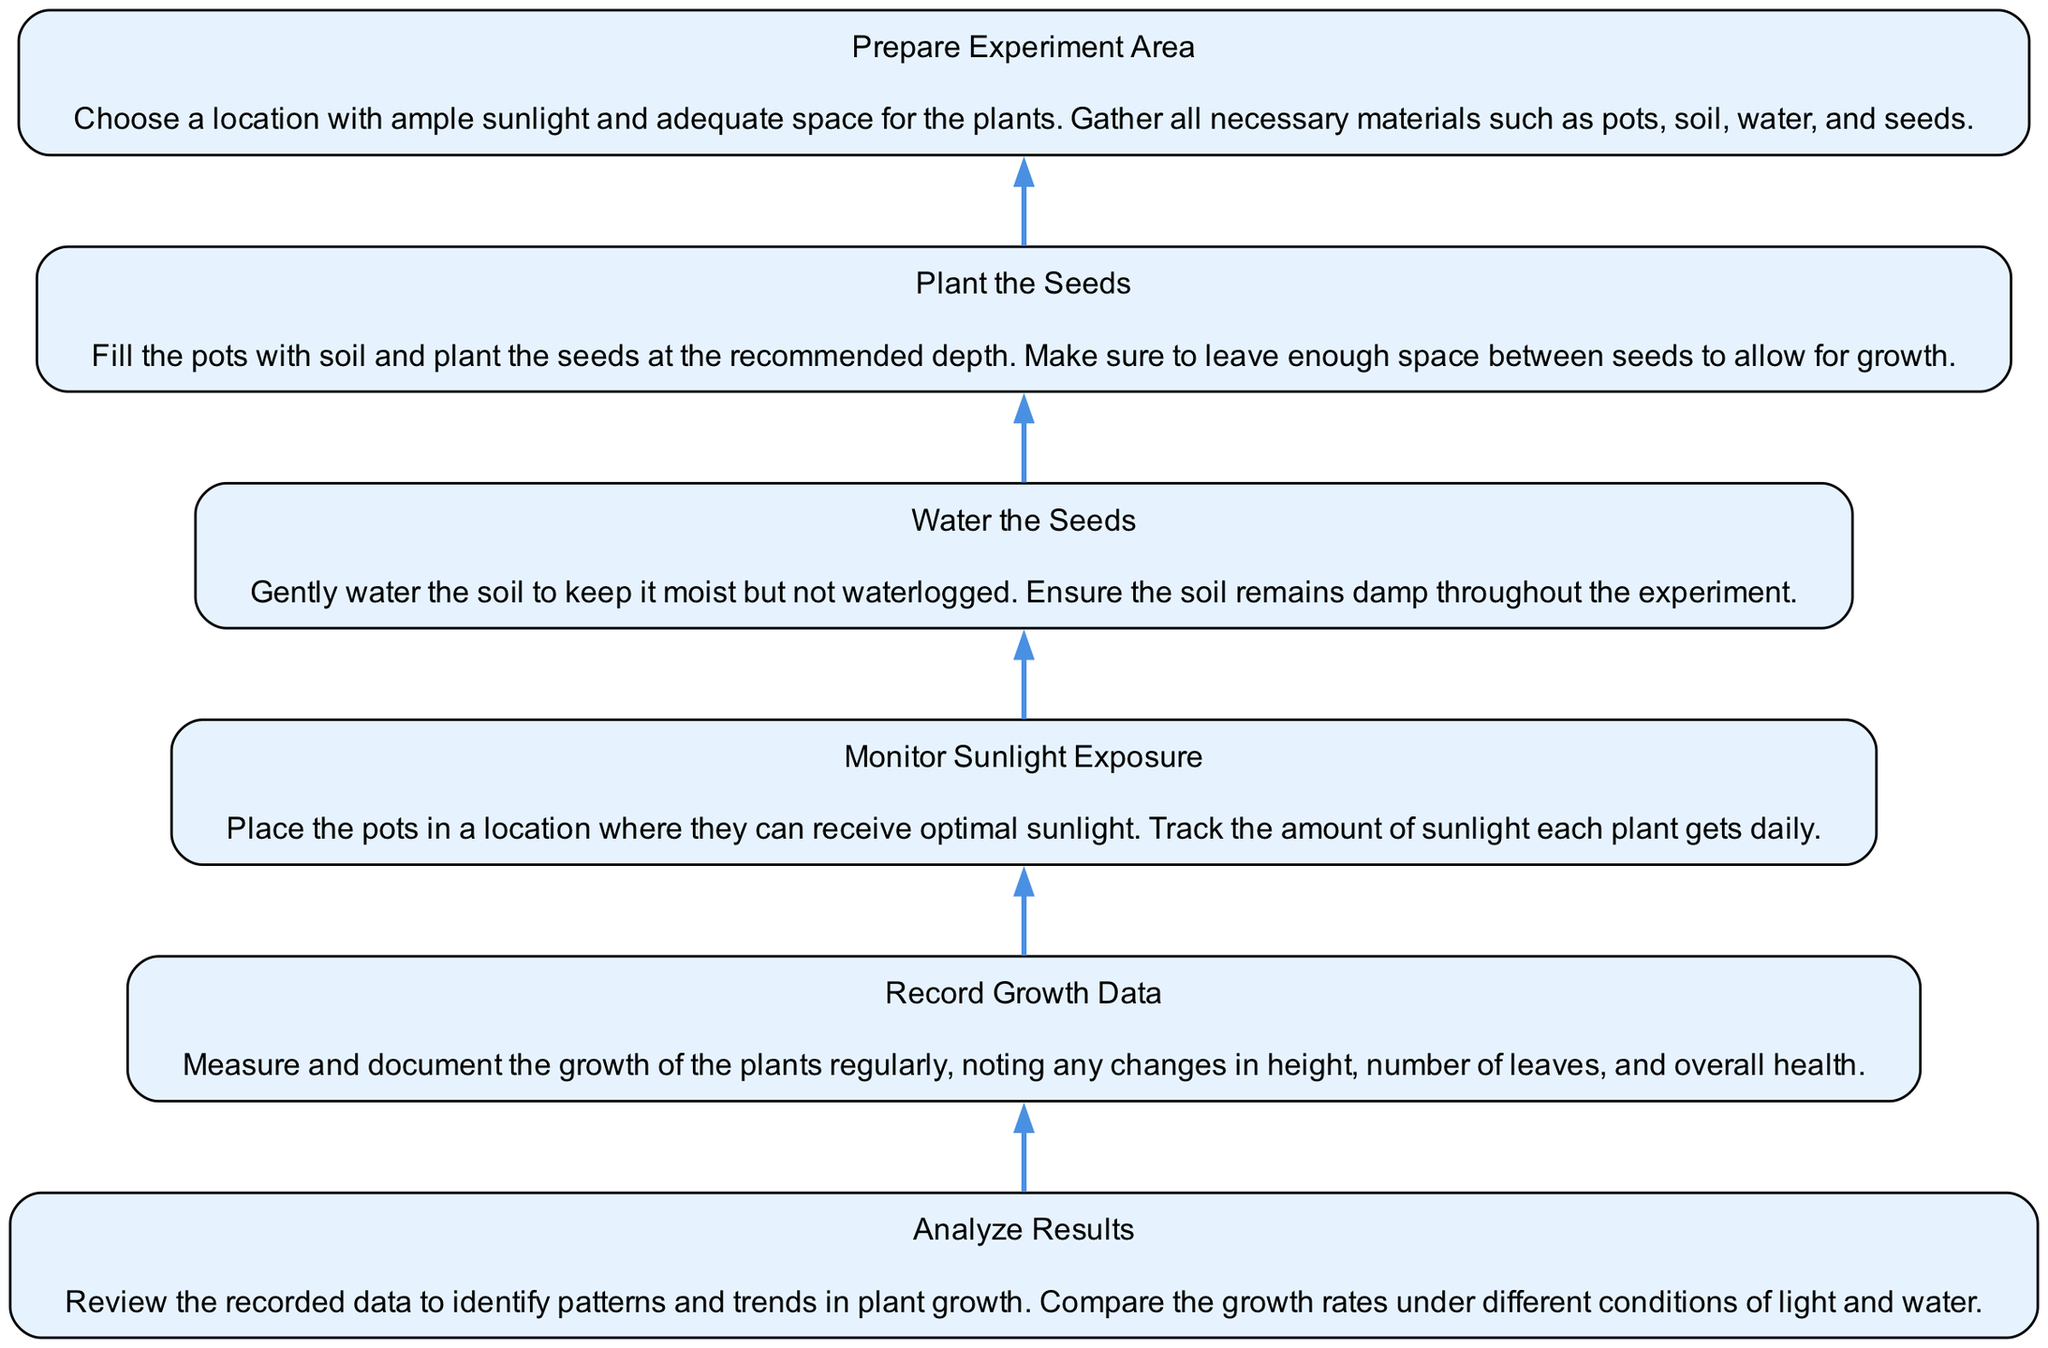What is the first step in the experiment? The bottom node of the diagram shows "Prepare Experiment Area," indicating that this is the first step in the process.
Answer: Prepare Experiment Area How many nodes are present in the diagram? By counting each distinct step outlined in the flow chart, we identify six nodes corresponding to six stages of the plant growth experiment.
Answer: 6 What follows after "Water the Seeds"? Looking at the flow of the chart, the node immediately above "Water the Seeds" is "Monitor Sunlight Exposure," which is the next step in the process.
Answer: Monitor Sunlight Exposure What step comes before "Analyze Results"? Referring to the diagram, "Record Growth Data" is the immediate predecessor to "Analyze Results," indicating that data collection must occur prior to analysis.
Answer: Record Growth Data Which step is at the top of the flow chart? The topmost node in the diagram represents the final outcome, which is "Analyze Results," showcasing the culmination of the experimental process.
Answer: Analyze Results What do all steps lead to in this experiment? Tracing through the flow from the bottom to the top, all steps ultimately lead to "Analyze Results," highlighting that each step is essential for producing useful data for analysis.
Answer: Analyze Results What is the relationship between "Plant the Seeds" and "Water the Seeds"? The flow chart demonstrates a direct sequential relationship where "Plant the Seeds" is the step that leads into "Water the Seeds," indicating that watering follows planting.
Answer: Sequential relationship What stage involves measuring plant growth? The node labeled "Record Growth Data" states that this step involves measuring and documenting the growth of the plants.
Answer: Record Growth Data How does the chart show the progression of the experiment? The diagram illustrates a upward flow where each consecutive step builds upon the previous one, indicating a structured and progressive approach to conducting the experiment.
Answer: Upward flow 